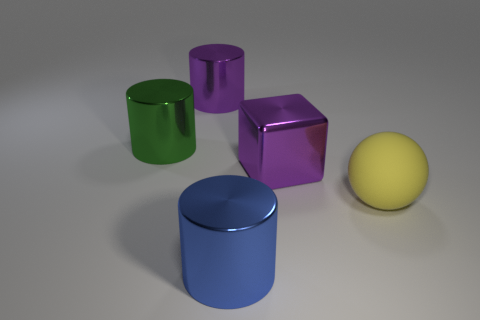Add 4 big green metal things. How many objects exist? 9 Subtract all cylinders. How many objects are left? 2 Subtract all large rubber things. Subtract all green matte things. How many objects are left? 4 Add 5 metal things. How many metal things are left? 9 Add 5 purple rubber spheres. How many purple rubber spheres exist? 5 Subtract 0 green spheres. How many objects are left? 5 